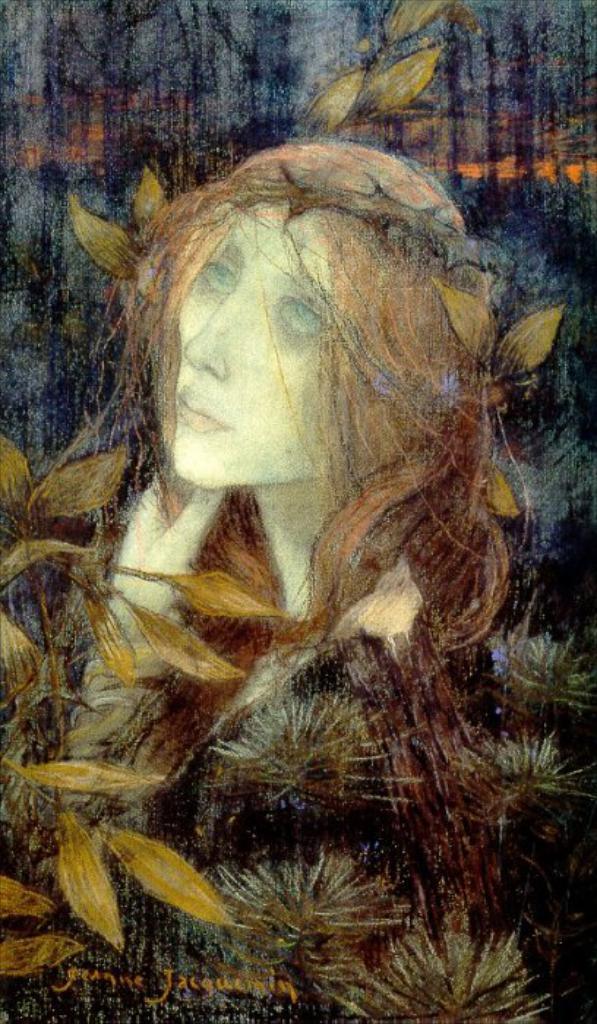Please provide a concise description of this image. We can see painting of a woman, plant and leaves. In the bottom left of the image we can see text. 